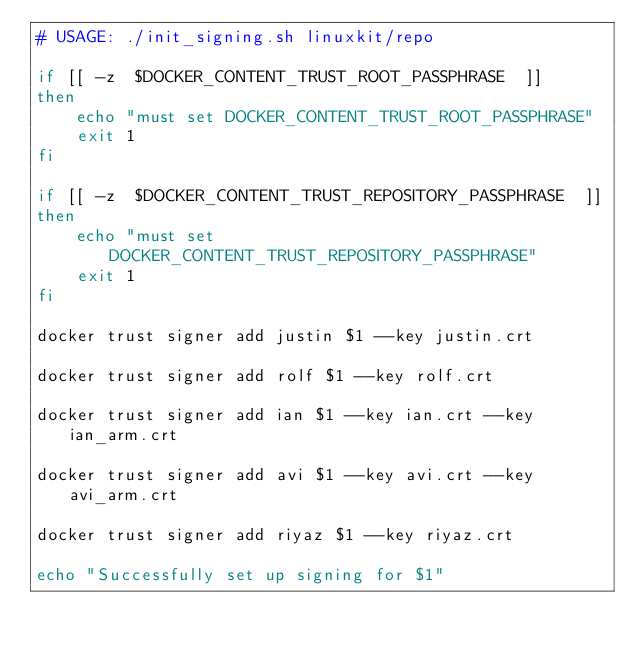Convert code to text. <code><loc_0><loc_0><loc_500><loc_500><_Bash_># USAGE: ./init_signing.sh linuxkit/repo

if [[ -z  $DOCKER_CONTENT_TRUST_ROOT_PASSPHRASE  ]]
then
    echo "must set DOCKER_CONTENT_TRUST_ROOT_PASSPHRASE"
    exit 1
fi

if [[ -z  $DOCKER_CONTENT_TRUST_REPOSITORY_PASSPHRASE  ]]
then
    echo "must set DOCKER_CONTENT_TRUST_REPOSITORY_PASSPHRASE"
    exit 1
fi

docker trust signer add justin $1 --key justin.crt

docker trust signer add rolf $1 --key rolf.crt

docker trust signer add ian $1 --key ian.crt --key ian_arm.crt

docker trust signer add avi $1 --key avi.crt --key avi_arm.crt

docker trust signer add riyaz $1 --key riyaz.crt

echo "Successfully set up signing for $1"
</code> 